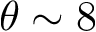<formula> <loc_0><loc_0><loc_500><loc_500>\theta \sim 8</formula> 